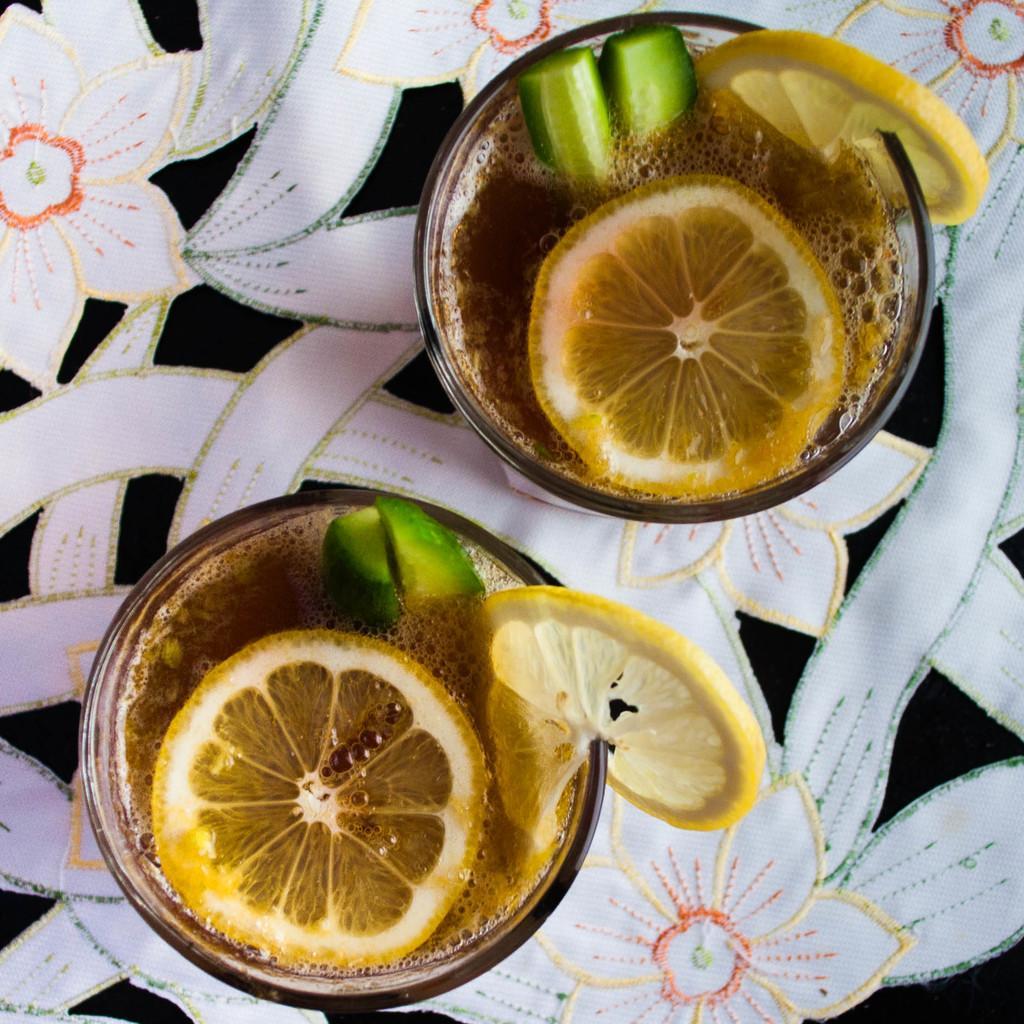In one or two sentences, can you explain what this image depicts? In this image I can see the bowls with food. The food is in brown, yellow and green color. These are on the white, black and orange color sheet. 